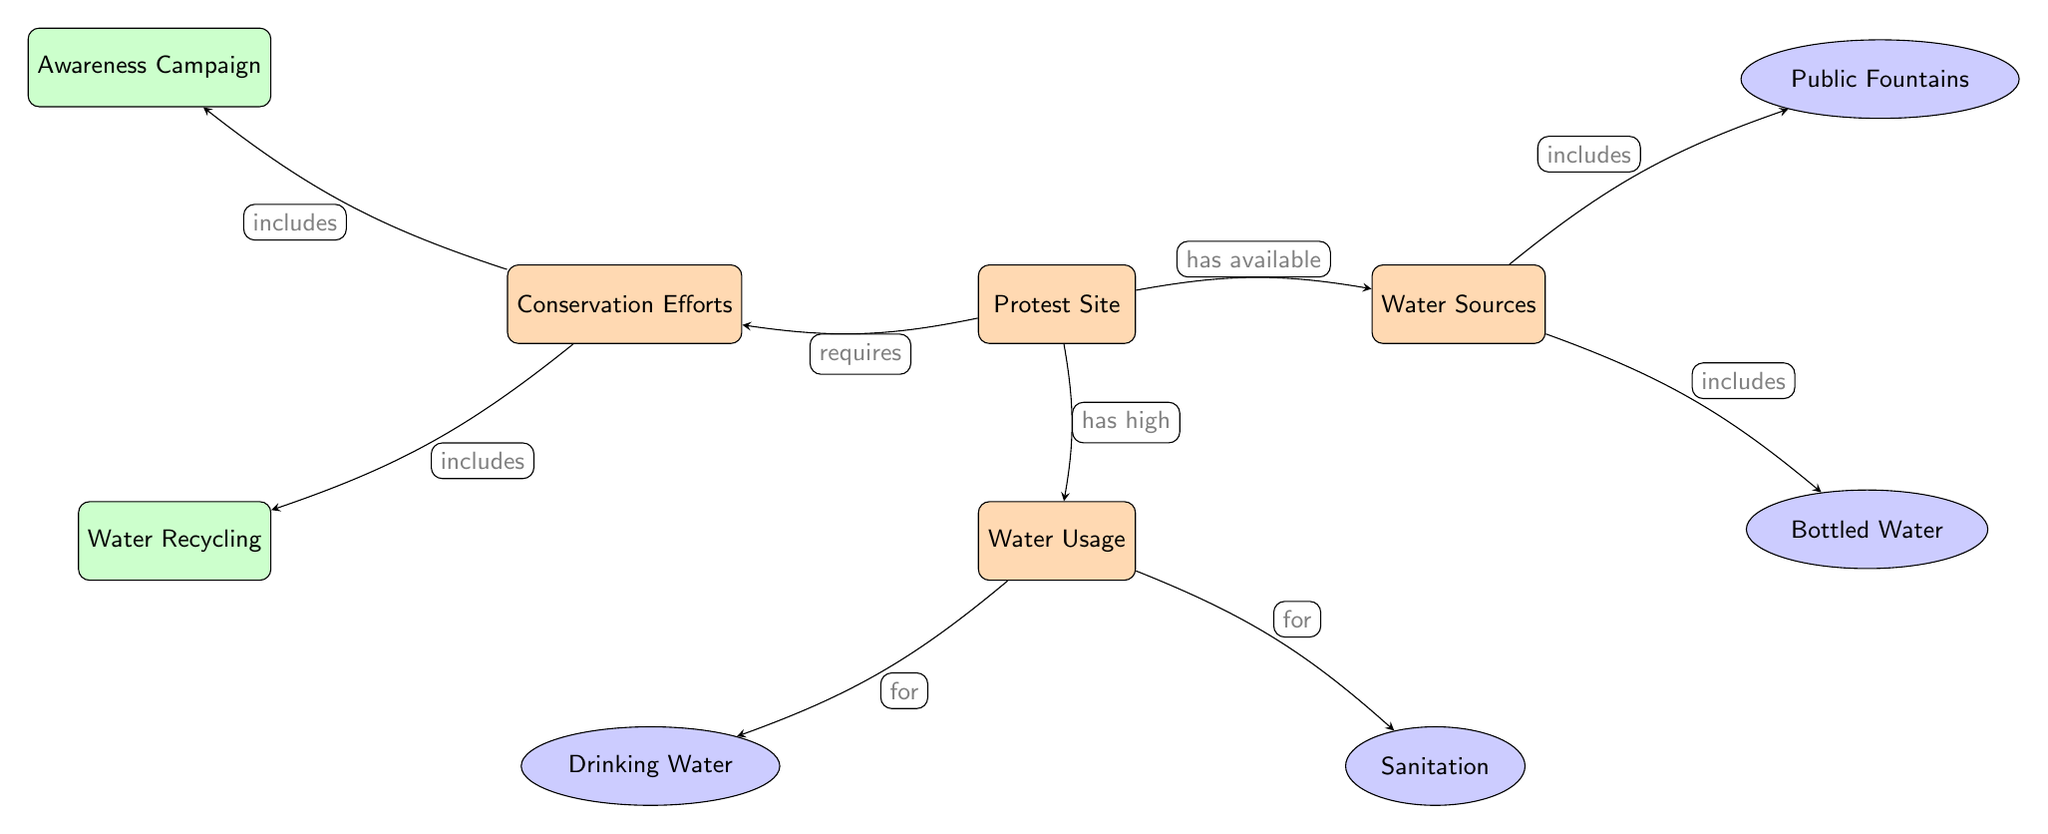What is the main node representing the site of action? The main node is labeled "Protest Site," which signifies where the activities are taking place. It is the starting point of the directed relationships in the diagram.
Answer: Protest Site How many secondary nodes are connected to the Water Usage node? The Water Usage node is connected to two secondary nodes: "Drinking Water" and "Sanitation." They represent specific categories of water use.
Answer: 2 What type of conservation effort includes promoting public awareness? The node "Awareness Campaign" is designed to increase public knowledge and encourage conservation efforts. It is directly linked as a secondary effort under Conservation Efforts.
Answer: Awareness Campaign From the Protest Site, which water source includes bottled water? The arrow from the Water Sources node indicates that "Bottled Water" is one of the water sources available at the protest site. This relationship illustrates part of the water source options.
Answer: Bottled Water What is the relationship between Conservation Efforts and Water Recycling? The diagram shows that "Water Recycling" is included in the Conservation Efforts, indicating that it is part of the strategies proposed to conserve water at the protest site.
Answer: includes How does the diagram represent the impact of protests on water usage? The diagram represents this relationship by showing that the "Protest Site" has high "Water Usage," which indicates that areas with protests tend to consume significant amounts of water for various purposes.
Answer: has high What are the two categories of water sources depicted in the diagram? The two categories of water sources are "Bottled Water" and "Public Fountains." These illustrate the sources through which water can be accessed at the protest site.
Answer: Bottled Water, Public Fountains Which main node requires conservation efforts? The "Protest Site" node requires conservation efforts, as shown by the arrow indicating that it necessitates these efforts to manage water usage effectively.
Answer: Conservation Efforts 